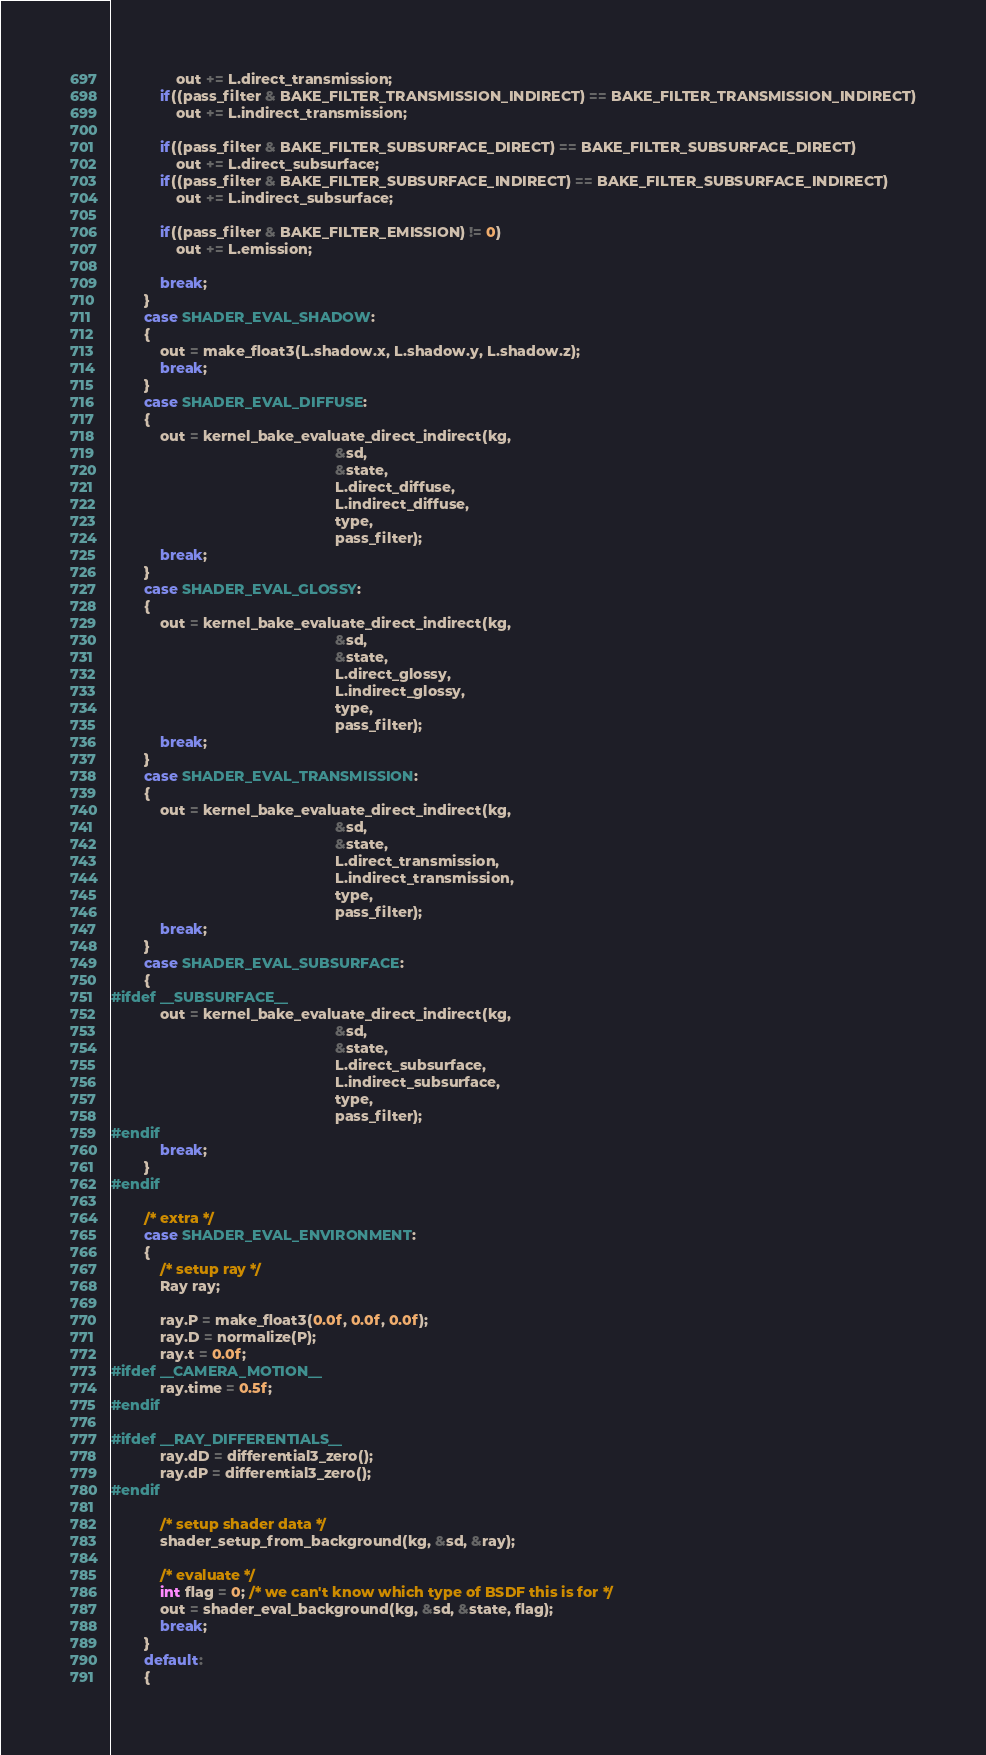Convert code to text. <code><loc_0><loc_0><loc_500><loc_500><_C_>				out += L.direct_transmission;
			if((pass_filter & BAKE_FILTER_TRANSMISSION_INDIRECT) == BAKE_FILTER_TRANSMISSION_INDIRECT)
				out += L.indirect_transmission;

			if((pass_filter & BAKE_FILTER_SUBSURFACE_DIRECT) == BAKE_FILTER_SUBSURFACE_DIRECT)
				out += L.direct_subsurface;
			if((pass_filter & BAKE_FILTER_SUBSURFACE_INDIRECT) == BAKE_FILTER_SUBSURFACE_INDIRECT)
				out += L.indirect_subsurface;

			if((pass_filter & BAKE_FILTER_EMISSION) != 0)
				out += L.emission;

			break;
		}
		case SHADER_EVAL_SHADOW:
		{
			out = make_float3(L.shadow.x, L.shadow.y, L.shadow.z);
			break;
		}
		case SHADER_EVAL_DIFFUSE:
		{
			out = kernel_bake_evaluate_direct_indirect(kg,
			                                           &sd,
			                                           &state,
			                                           L.direct_diffuse,
			                                           L.indirect_diffuse,
			                                           type,
			                                           pass_filter);
			break;
		}
		case SHADER_EVAL_GLOSSY:
		{
			out = kernel_bake_evaluate_direct_indirect(kg,
			                                           &sd,
			                                           &state,
			                                           L.direct_glossy,
			                                           L.indirect_glossy,
			                                           type,
			                                           pass_filter);
			break;
		}
		case SHADER_EVAL_TRANSMISSION:
		{
			out = kernel_bake_evaluate_direct_indirect(kg,
			                                           &sd,
			                                           &state,
			                                           L.direct_transmission,
			                                           L.indirect_transmission,
			                                           type,
			                                           pass_filter);
			break;
		}
		case SHADER_EVAL_SUBSURFACE:
		{
#ifdef __SUBSURFACE__
			out = kernel_bake_evaluate_direct_indirect(kg,
			                                           &sd,
			                                           &state,
			                                           L.direct_subsurface,
			                                           L.indirect_subsurface,
			                                           type,
			                                           pass_filter);
#endif
			break;
		}
#endif

		/* extra */
		case SHADER_EVAL_ENVIRONMENT:
		{
			/* setup ray */
			Ray ray;

			ray.P = make_float3(0.0f, 0.0f, 0.0f);
			ray.D = normalize(P);
			ray.t = 0.0f;
#ifdef __CAMERA_MOTION__
			ray.time = 0.5f;
#endif

#ifdef __RAY_DIFFERENTIALS__
			ray.dD = differential3_zero();
			ray.dP = differential3_zero();
#endif

			/* setup shader data */
			shader_setup_from_background(kg, &sd, &ray);

			/* evaluate */
			int flag = 0; /* we can't know which type of BSDF this is for */
			out = shader_eval_background(kg, &sd, &state, flag);
			break;
		}
		default:
		{</code> 